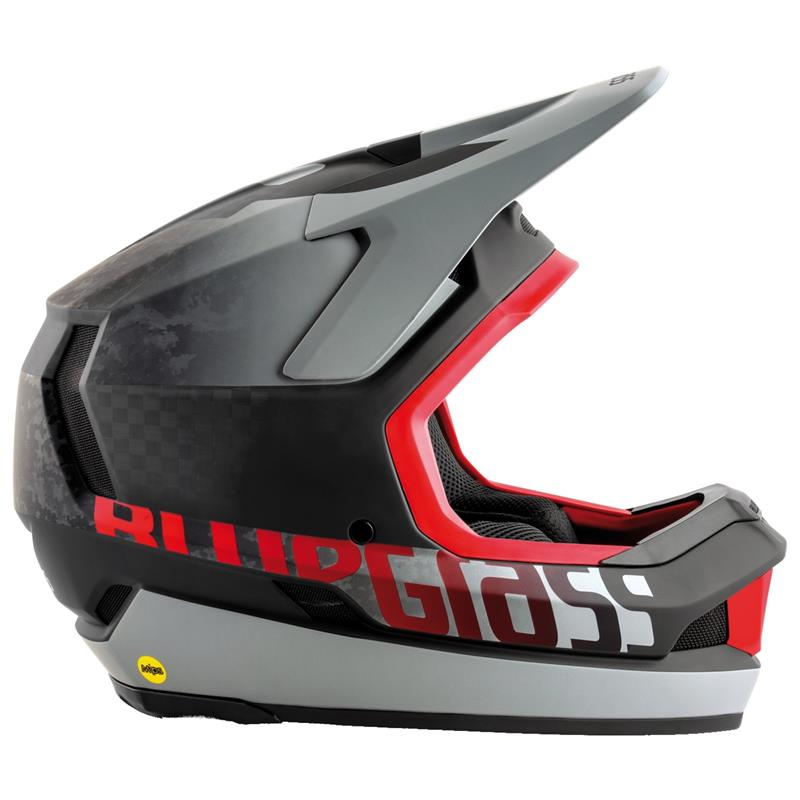If this helmet were used in a futuristic sports competition on another planet, what unique modifications would it likely need to achieve optimal performance? In a futuristic sports competition on another planet, this helmet would require several unique modifications to achieve optimal performance. Firstly, it would need advanced materials capable of withstanding extreme temperature variations, atmospheric differences, and potential radiation exposure. An integrated life support system providing breathable air and maintaining optimal internal pressure would be crucial. The helmet might also feature smart sensors to monitor the wearer's vital signs and environmental conditions, adjusting ventilation and temperature automatically. Enhanced communication systems, possibly with interplanetary range, and augmented reality displays for navigation and performance analytics would vastly improve situational awareness. Additionally, modular components allowing for adaptability to various terrains or sports activities, and a built-in propulsion system for zero-gravity environments, could maximize the helmet's versatility and functionality in this extraordinary setting. What might be the first thing an alien species would notice about this helmet, and how might they interpret its purpose purely based on its design? The first thing an alien species might notice about this helmet is its sleek, aerodynamic shape and robust construction. They might interpret its elongated visor and reinforced structure as a means of protection, deducing that it serves to safeguard the wearer from environmental hazards or impacts. The presence of the yellow certification sticker could be perceived as a mark of quality or safety compliance, hinting at some advanced form of quality control or regulation. The vents and ergonomic design might suggest that the helmet is engineered for comfort and prolonged use, potentially indicating its use in high-speed or high-risk activities. The visual elements such as the bold graphics and color scheme could also imply cultural significance or a display of technological sophistication. Overall, the aliens might conclude that this is a high-tech, protective gear designed for scenarios demanding both safety and performance. 